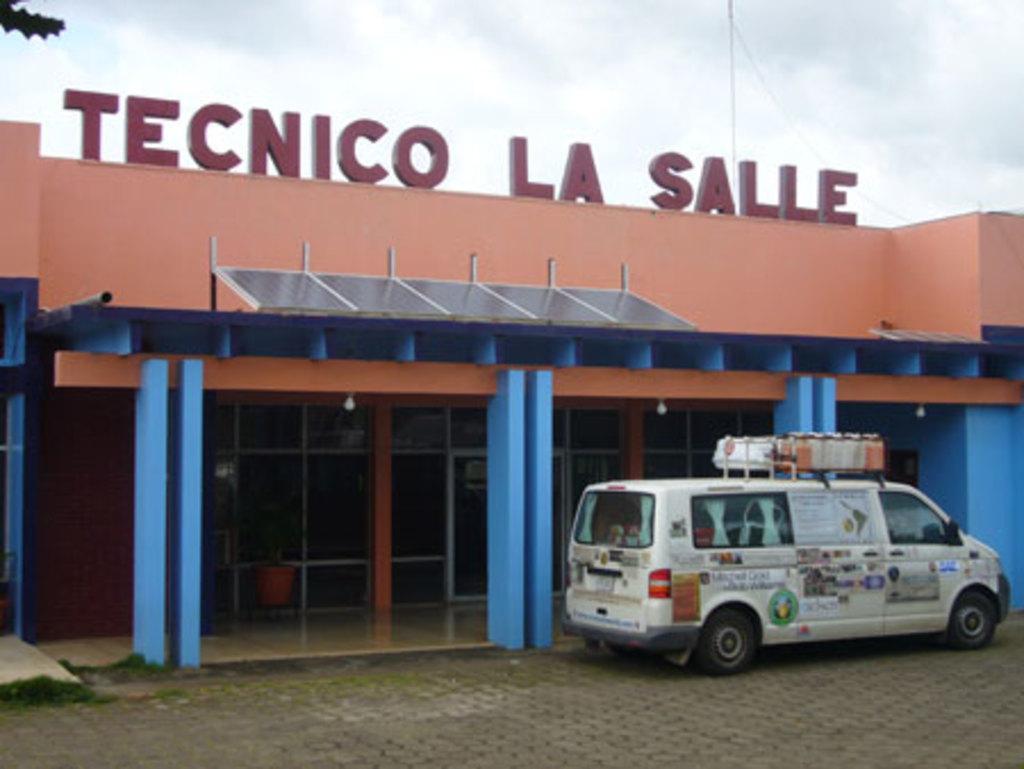Can you describe this image briefly? In this picture there is a white van parked in the front. Behind we can see the brown and blue color building. 